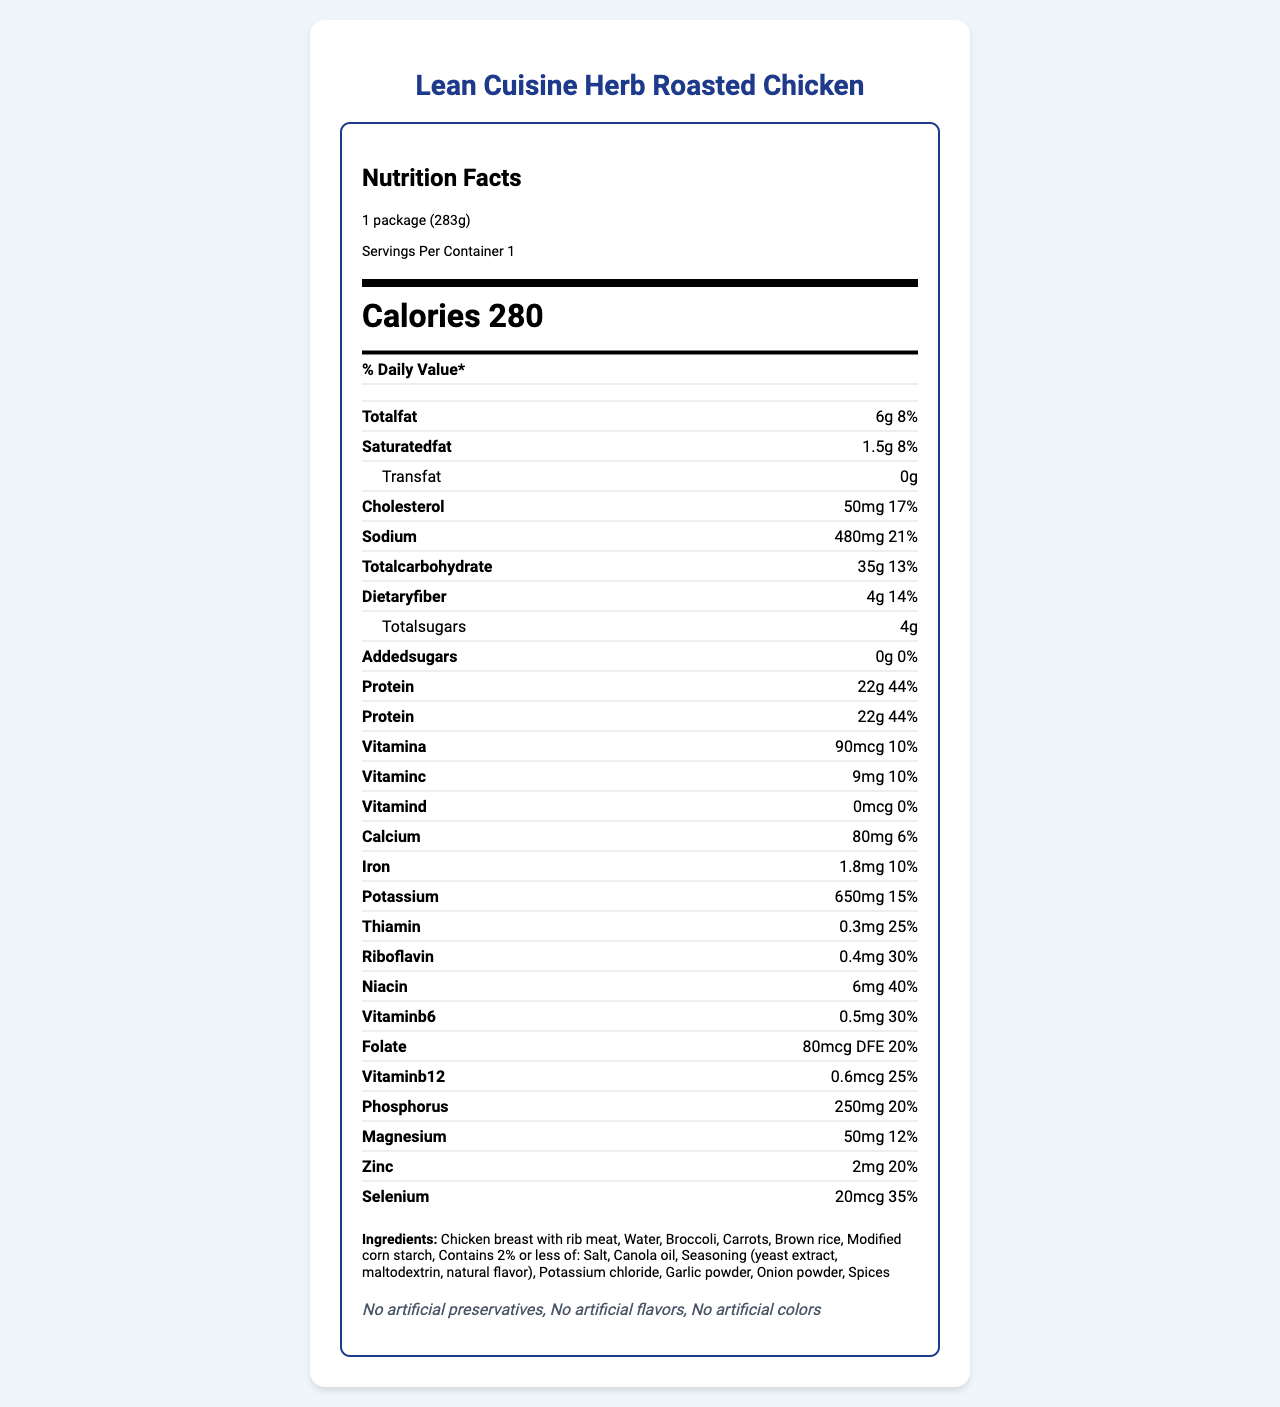what is the serving size of the meal? The document specifies the serving size as "1 package (283g)".
Answer: 1 package (283g) how many calories are in one serving of this product? The document mentions that there are 280 calories per serving.
Answer: 280 what is the percentage daily value for sodium in this meal? The document lists sodium content as having a 21% daily value.
Answer: 21% which company manufactures this product? The document provides information that the manufacturer is "Nestlé USA".
Answer: Nestlé USA what are the preparation instructions for this meal? The preparation instructions are clearly listed in the document in a step-by-step format.
Answer: Leave film on tray, do not vent. Cook on high for 3 minutes. Carefully remove from microwave and let stand for 1 minute. Peel back film, stir and serve. how much total carbohydrate is in the meal? The document states that the total carbohydrate is 35g.
Answer: 35g which of the following is not listed as an ingredient? A. Chicken breast with rib meat B. Sodium chloride C. Potassium chloride The document lists "Salt" and "Potassium chloride" but does not list "Sodium chloride".
Answer: B what certifications does this product have? A. Certified organic B. No artificial preservatives C. Gluten-free The document mentions that the meal has certifications for "No artificial preservatives", "No artificial flavors", and "No artificial colors".
Answer: B does this product contain any allergens? The document specifically lists "None" under the allergens section.
Answer: No what is the primary idea of the document? The entire document is focused on giving detailed information about the nutritional content, ingredients, and other relevant product details for consumers.
Answer: The document provides comprehensive nutritional information, ingredient list, certifications, preparation instructions, and manufacturing details for the Lean Cuisine Herb Roasted Chicken frozen meal. what is the carbon footprint statement in the document? The document mentions that this product has a 30% lower carbon footprint compared to average frozen meals.
Answer: 30% lower carbon footprint compared to average frozen meals how much vitamin A does one serving of this meal contain? The document lists the amount of Vitamin A as 90 mcg.
Answer: 90 mcg how many grams of dietary fiber does the meal provide? The document states that the meal provides 4g of dietary fiber.
Answer: 4g which nutrient has the highest daily value percentage? Among all listed nutrients, protein has the highest daily value percentage at 44%.
Answer: Protein (44%) what is the calcium content per serving of this meal? A. 50 mg B. 80 mg C. 100 mg D. 120 mg The document indicates that the calcium content per serving is 80 mg.
Answer: B can the cardboard box of the meal be recycled? The document notes that the packaging recyclability includes a "Cardboard box recyclable where facilities exist".
Answer: Yes what is the cooking time in the microwave? The document's preparation instructions specify a cooking time of 3 minutes in the microwave.
Answer: 3 minutes how many mcg of selenium does this meal contain? The document lists selenium content as 20 mcg.
Answer: 20 mcg what is the website for the manufacturer of this meal? The document provides the manufacturer's website as "www.leancuisine.com".
Answer: www.leancuisine.com what is the total fat content in one serving? The document states that the total fat content in one serving is 6g.
Answer: 6g how much vitamin B12 is in the meal? The document lists the amount of Vitamin B12 as 0.6 mcg per serving.
Answer: 0.6 mcg who is the CEO of the company that manufactures this product? The document does not provide information about the CEO of the company.
Answer: Not enough information 